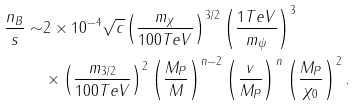<formula> <loc_0><loc_0><loc_500><loc_500>\frac { n _ { B } } { s } \sim & 2 \times 1 0 ^ { - 4 } \sqrt { c } \left ( \frac { m _ { \chi } } { 1 0 0 T e V } \right ) ^ { 3 / 2 } \left ( \frac { 1 T e V } { m _ { \psi } } \right ) ^ { 3 } \\ & \times \left ( \frac { m _ { 3 / 2 } } { 1 0 0 T e V } \right ) ^ { 2 } \left ( \frac { M _ { P } } { M } \right ) ^ { n - 2 } \left ( \frac { v } { M _ { P } } \right ) ^ { n } \left ( \frac { M _ { P } } { \chi _ { 0 } } \right ) ^ { 2 } .</formula> 